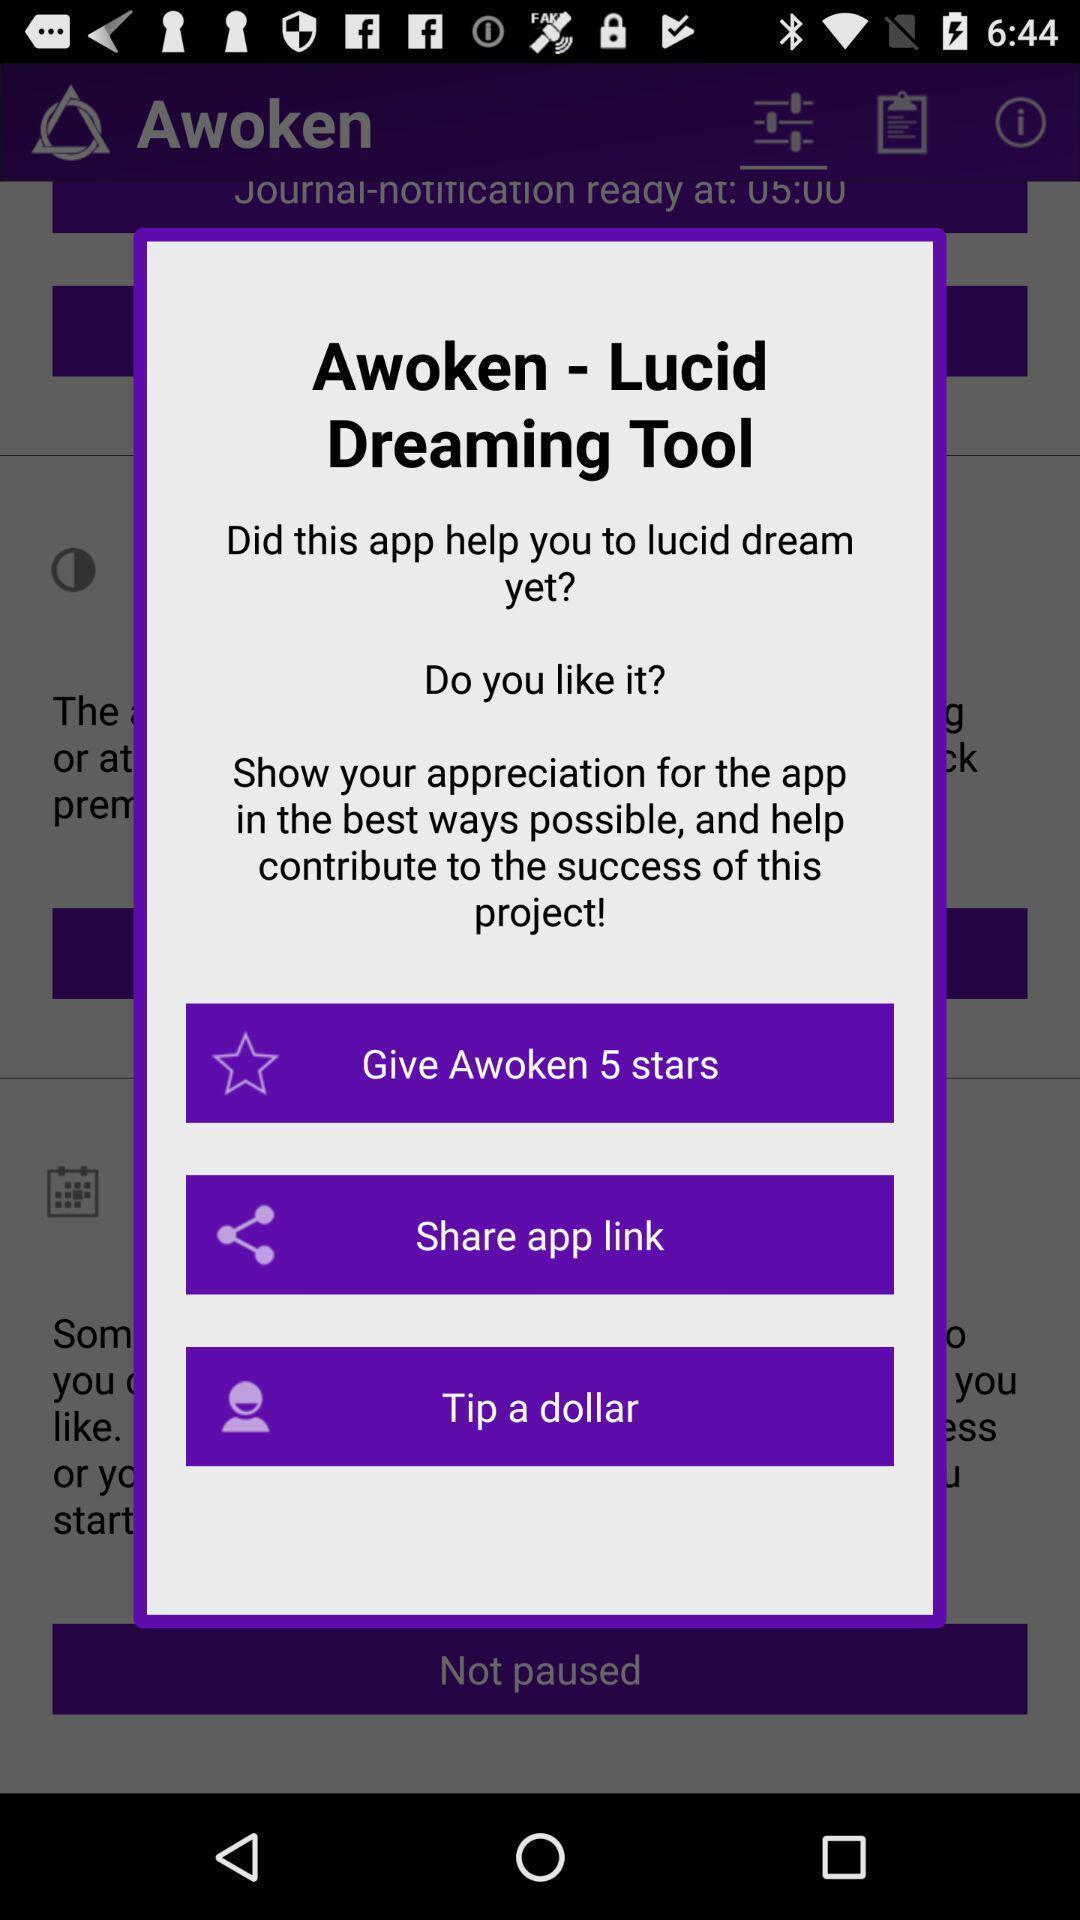What can you discern from this picture? Pop-up showing the rating and sharing options. 